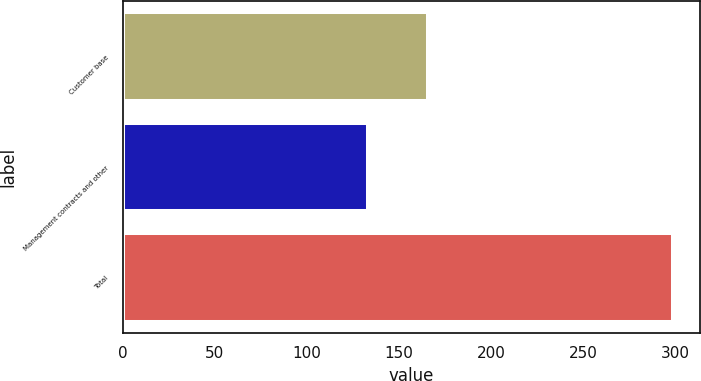<chart> <loc_0><loc_0><loc_500><loc_500><bar_chart><fcel>Customer base<fcel>Management contracts and other<fcel>Total<nl><fcel>165.6<fcel>133.2<fcel>298.8<nl></chart> 